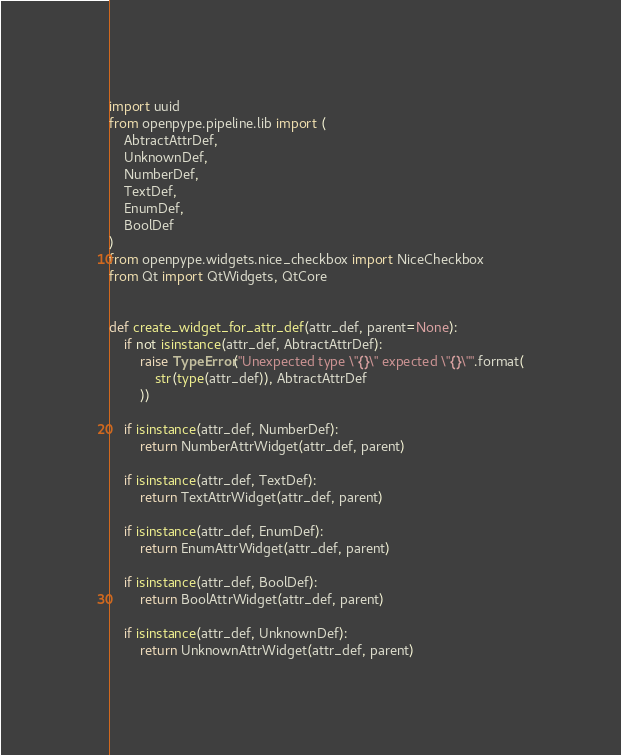<code> <loc_0><loc_0><loc_500><loc_500><_Python_>import uuid
from openpype.pipeline.lib import (
    AbtractAttrDef,
    UnknownDef,
    NumberDef,
    TextDef,
    EnumDef,
    BoolDef
)
from openpype.widgets.nice_checkbox import NiceCheckbox
from Qt import QtWidgets, QtCore


def create_widget_for_attr_def(attr_def, parent=None):
    if not isinstance(attr_def, AbtractAttrDef):
        raise TypeError("Unexpected type \"{}\" expected \"{}\"".format(
            str(type(attr_def)), AbtractAttrDef
        ))

    if isinstance(attr_def, NumberDef):
        return NumberAttrWidget(attr_def, parent)

    if isinstance(attr_def, TextDef):
        return TextAttrWidget(attr_def, parent)

    if isinstance(attr_def, EnumDef):
        return EnumAttrWidget(attr_def, parent)

    if isinstance(attr_def, BoolDef):
        return BoolAttrWidget(attr_def, parent)

    if isinstance(attr_def, UnknownDef):
        return UnknownAttrWidget(attr_def, parent)
</code> 